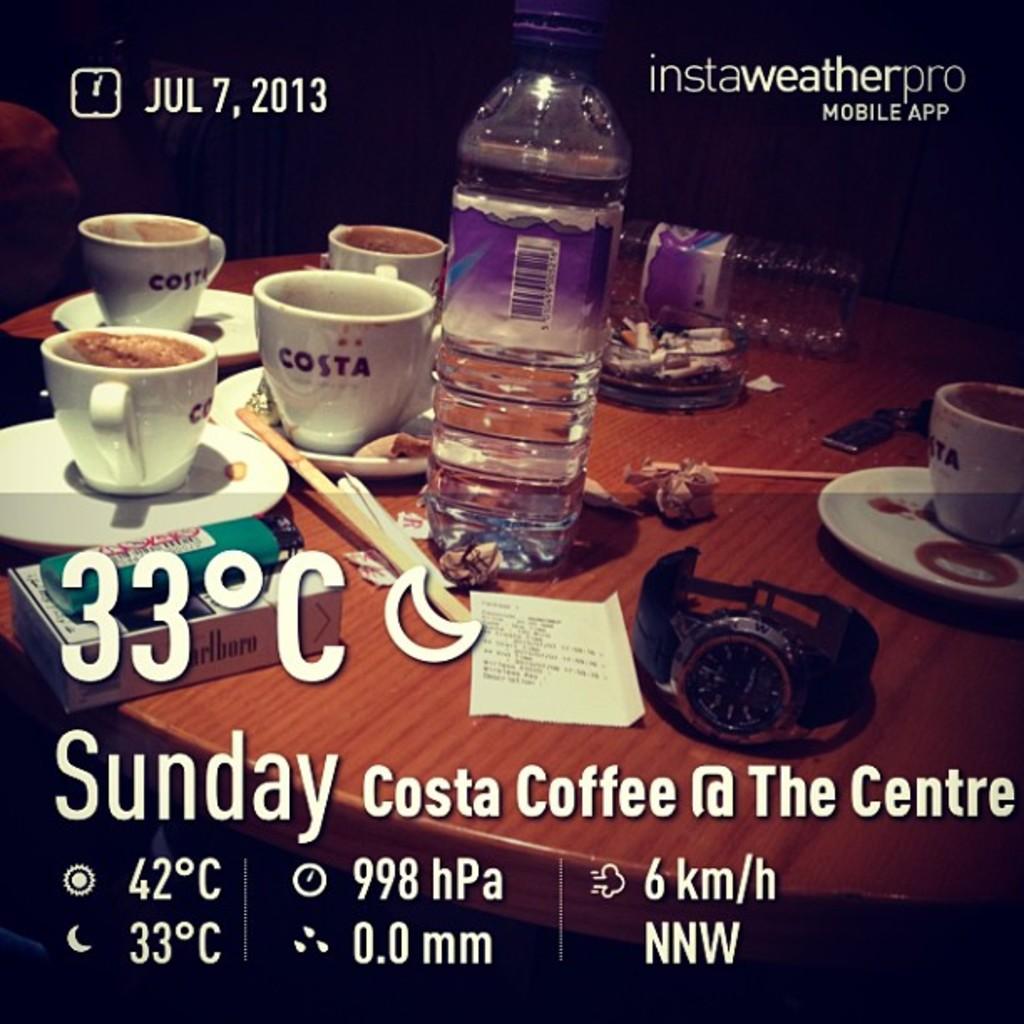What year is this from?
Give a very brief answer. 2013. What is the temperature?
Your response must be concise. 33. 